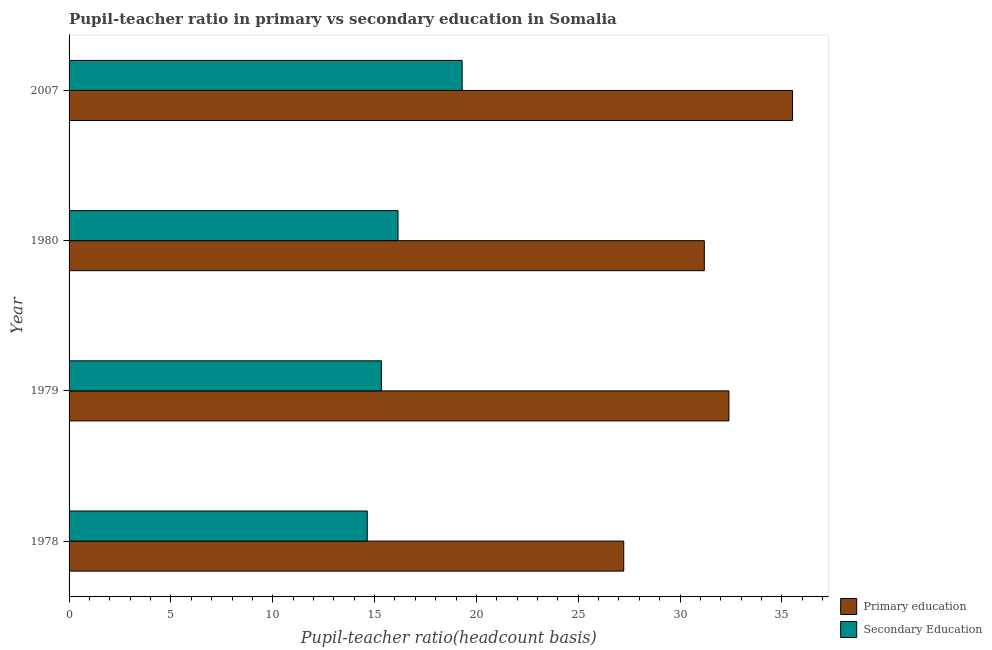How many bars are there on the 1st tick from the top?
Keep it short and to the point. 2. In how many cases, is the number of bars for a given year not equal to the number of legend labels?
Your answer should be very brief. 0. What is the pupil-teacher ratio in primary education in 2007?
Keep it short and to the point. 35.52. Across all years, what is the maximum pupil teacher ratio on secondary education?
Your answer should be compact. 19.3. Across all years, what is the minimum pupil teacher ratio on secondary education?
Offer a terse response. 14.64. In which year was the pupil teacher ratio on secondary education minimum?
Your answer should be very brief. 1978. What is the total pupil-teacher ratio in primary education in the graph?
Your response must be concise. 126.34. What is the difference between the pupil-teacher ratio in primary education in 1978 and that in 1980?
Offer a very short reply. -3.96. What is the difference between the pupil-teacher ratio in primary education in 1978 and the pupil teacher ratio on secondary education in 2007?
Your response must be concise. 7.93. What is the average pupil teacher ratio on secondary education per year?
Provide a succinct answer. 16.36. In the year 1979, what is the difference between the pupil teacher ratio on secondary education and pupil-teacher ratio in primary education?
Ensure brevity in your answer.  -17.06. What is the ratio of the pupil teacher ratio on secondary education in 1980 to that in 2007?
Keep it short and to the point. 0.84. Is the difference between the pupil teacher ratio on secondary education in 1978 and 1979 greater than the difference between the pupil-teacher ratio in primary education in 1978 and 1979?
Keep it short and to the point. Yes. What is the difference between the highest and the second highest pupil teacher ratio on secondary education?
Provide a succinct answer. 3.15. What is the difference between the highest and the lowest pupil teacher ratio on secondary education?
Your response must be concise. 4.66. In how many years, is the pupil-teacher ratio in primary education greater than the average pupil-teacher ratio in primary education taken over all years?
Your response must be concise. 2. Is the sum of the pupil-teacher ratio in primary education in 1978 and 2007 greater than the maximum pupil teacher ratio on secondary education across all years?
Keep it short and to the point. Yes. What does the 1st bar from the top in 1980 represents?
Your answer should be very brief. Secondary Education. How many bars are there?
Provide a short and direct response. 8. How many years are there in the graph?
Make the answer very short. 4. Are the values on the major ticks of X-axis written in scientific E-notation?
Ensure brevity in your answer.  No. Does the graph contain any zero values?
Offer a very short reply. No. How many legend labels are there?
Make the answer very short. 2. How are the legend labels stacked?
Keep it short and to the point. Vertical. What is the title of the graph?
Keep it short and to the point. Pupil-teacher ratio in primary vs secondary education in Somalia. Does "Girls" appear as one of the legend labels in the graph?
Make the answer very short. No. What is the label or title of the X-axis?
Provide a succinct answer. Pupil-teacher ratio(headcount basis). What is the label or title of the Y-axis?
Provide a short and direct response. Year. What is the Pupil-teacher ratio(headcount basis) in Primary education in 1978?
Give a very brief answer. 27.23. What is the Pupil-teacher ratio(headcount basis) in Secondary Education in 1978?
Keep it short and to the point. 14.64. What is the Pupil-teacher ratio(headcount basis) in Primary education in 1979?
Provide a short and direct response. 32.4. What is the Pupil-teacher ratio(headcount basis) of Secondary Education in 1979?
Give a very brief answer. 15.33. What is the Pupil-teacher ratio(headcount basis) in Primary education in 1980?
Your response must be concise. 31.19. What is the Pupil-teacher ratio(headcount basis) in Secondary Education in 1980?
Ensure brevity in your answer.  16.15. What is the Pupil-teacher ratio(headcount basis) of Primary education in 2007?
Offer a terse response. 35.52. What is the Pupil-teacher ratio(headcount basis) of Secondary Education in 2007?
Keep it short and to the point. 19.3. Across all years, what is the maximum Pupil-teacher ratio(headcount basis) of Primary education?
Provide a short and direct response. 35.52. Across all years, what is the maximum Pupil-teacher ratio(headcount basis) in Secondary Education?
Make the answer very short. 19.3. Across all years, what is the minimum Pupil-teacher ratio(headcount basis) of Primary education?
Keep it short and to the point. 27.23. Across all years, what is the minimum Pupil-teacher ratio(headcount basis) in Secondary Education?
Your answer should be very brief. 14.64. What is the total Pupil-teacher ratio(headcount basis) in Primary education in the graph?
Give a very brief answer. 126.34. What is the total Pupil-teacher ratio(headcount basis) in Secondary Education in the graph?
Offer a very short reply. 65.42. What is the difference between the Pupil-teacher ratio(headcount basis) in Primary education in 1978 and that in 1979?
Your answer should be compact. -5.16. What is the difference between the Pupil-teacher ratio(headcount basis) of Secondary Education in 1978 and that in 1979?
Your answer should be very brief. -0.69. What is the difference between the Pupil-teacher ratio(headcount basis) in Primary education in 1978 and that in 1980?
Your response must be concise. -3.96. What is the difference between the Pupil-teacher ratio(headcount basis) in Secondary Education in 1978 and that in 1980?
Your answer should be compact. -1.51. What is the difference between the Pupil-teacher ratio(headcount basis) of Primary education in 1978 and that in 2007?
Offer a terse response. -8.29. What is the difference between the Pupil-teacher ratio(headcount basis) of Secondary Education in 1978 and that in 2007?
Your response must be concise. -4.66. What is the difference between the Pupil-teacher ratio(headcount basis) in Primary education in 1979 and that in 1980?
Make the answer very short. 1.21. What is the difference between the Pupil-teacher ratio(headcount basis) of Secondary Education in 1979 and that in 1980?
Provide a short and direct response. -0.82. What is the difference between the Pupil-teacher ratio(headcount basis) in Primary education in 1979 and that in 2007?
Give a very brief answer. -3.12. What is the difference between the Pupil-teacher ratio(headcount basis) of Secondary Education in 1979 and that in 2007?
Make the answer very short. -3.97. What is the difference between the Pupil-teacher ratio(headcount basis) of Primary education in 1980 and that in 2007?
Your answer should be compact. -4.33. What is the difference between the Pupil-teacher ratio(headcount basis) of Secondary Education in 1980 and that in 2007?
Keep it short and to the point. -3.15. What is the difference between the Pupil-teacher ratio(headcount basis) of Primary education in 1978 and the Pupil-teacher ratio(headcount basis) of Secondary Education in 1979?
Your response must be concise. 11.9. What is the difference between the Pupil-teacher ratio(headcount basis) of Primary education in 1978 and the Pupil-teacher ratio(headcount basis) of Secondary Education in 1980?
Your response must be concise. 11.08. What is the difference between the Pupil-teacher ratio(headcount basis) in Primary education in 1978 and the Pupil-teacher ratio(headcount basis) in Secondary Education in 2007?
Offer a very short reply. 7.93. What is the difference between the Pupil-teacher ratio(headcount basis) in Primary education in 1979 and the Pupil-teacher ratio(headcount basis) in Secondary Education in 1980?
Make the answer very short. 16.25. What is the difference between the Pupil-teacher ratio(headcount basis) in Primary education in 1979 and the Pupil-teacher ratio(headcount basis) in Secondary Education in 2007?
Keep it short and to the point. 13.1. What is the difference between the Pupil-teacher ratio(headcount basis) of Primary education in 1980 and the Pupil-teacher ratio(headcount basis) of Secondary Education in 2007?
Provide a short and direct response. 11.89. What is the average Pupil-teacher ratio(headcount basis) in Primary education per year?
Provide a succinct answer. 31.59. What is the average Pupil-teacher ratio(headcount basis) in Secondary Education per year?
Offer a terse response. 16.36. In the year 1978, what is the difference between the Pupil-teacher ratio(headcount basis) in Primary education and Pupil-teacher ratio(headcount basis) in Secondary Education?
Your answer should be very brief. 12.59. In the year 1979, what is the difference between the Pupil-teacher ratio(headcount basis) of Primary education and Pupil-teacher ratio(headcount basis) of Secondary Education?
Offer a very short reply. 17.06. In the year 1980, what is the difference between the Pupil-teacher ratio(headcount basis) of Primary education and Pupil-teacher ratio(headcount basis) of Secondary Education?
Keep it short and to the point. 15.04. In the year 2007, what is the difference between the Pupil-teacher ratio(headcount basis) in Primary education and Pupil-teacher ratio(headcount basis) in Secondary Education?
Provide a short and direct response. 16.22. What is the ratio of the Pupil-teacher ratio(headcount basis) of Primary education in 1978 to that in 1979?
Your response must be concise. 0.84. What is the ratio of the Pupil-teacher ratio(headcount basis) of Secondary Education in 1978 to that in 1979?
Provide a short and direct response. 0.95. What is the ratio of the Pupil-teacher ratio(headcount basis) in Primary education in 1978 to that in 1980?
Offer a terse response. 0.87. What is the ratio of the Pupil-teacher ratio(headcount basis) of Secondary Education in 1978 to that in 1980?
Provide a short and direct response. 0.91. What is the ratio of the Pupil-teacher ratio(headcount basis) in Primary education in 1978 to that in 2007?
Your answer should be compact. 0.77. What is the ratio of the Pupil-teacher ratio(headcount basis) in Secondary Education in 1978 to that in 2007?
Provide a succinct answer. 0.76. What is the ratio of the Pupil-teacher ratio(headcount basis) in Primary education in 1979 to that in 1980?
Offer a terse response. 1.04. What is the ratio of the Pupil-teacher ratio(headcount basis) of Secondary Education in 1979 to that in 1980?
Give a very brief answer. 0.95. What is the ratio of the Pupil-teacher ratio(headcount basis) of Primary education in 1979 to that in 2007?
Offer a very short reply. 0.91. What is the ratio of the Pupil-teacher ratio(headcount basis) of Secondary Education in 1979 to that in 2007?
Offer a very short reply. 0.79. What is the ratio of the Pupil-teacher ratio(headcount basis) in Primary education in 1980 to that in 2007?
Keep it short and to the point. 0.88. What is the ratio of the Pupil-teacher ratio(headcount basis) of Secondary Education in 1980 to that in 2007?
Provide a succinct answer. 0.84. What is the difference between the highest and the second highest Pupil-teacher ratio(headcount basis) in Primary education?
Give a very brief answer. 3.12. What is the difference between the highest and the second highest Pupil-teacher ratio(headcount basis) of Secondary Education?
Offer a terse response. 3.15. What is the difference between the highest and the lowest Pupil-teacher ratio(headcount basis) of Primary education?
Your answer should be compact. 8.29. What is the difference between the highest and the lowest Pupil-teacher ratio(headcount basis) of Secondary Education?
Offer a terse response. 4.66. 